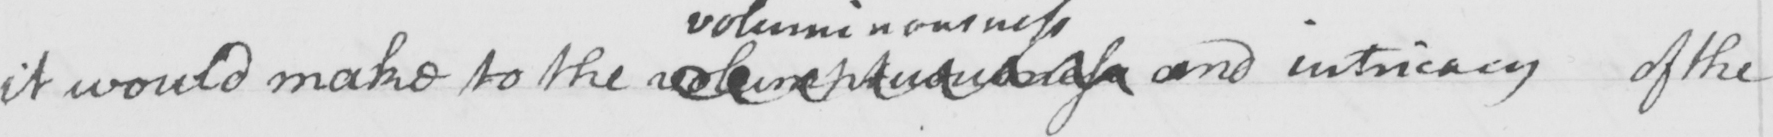Please transcribe the handwritten text in this image. it would make to the  voluminuousness  and intricacy of the 